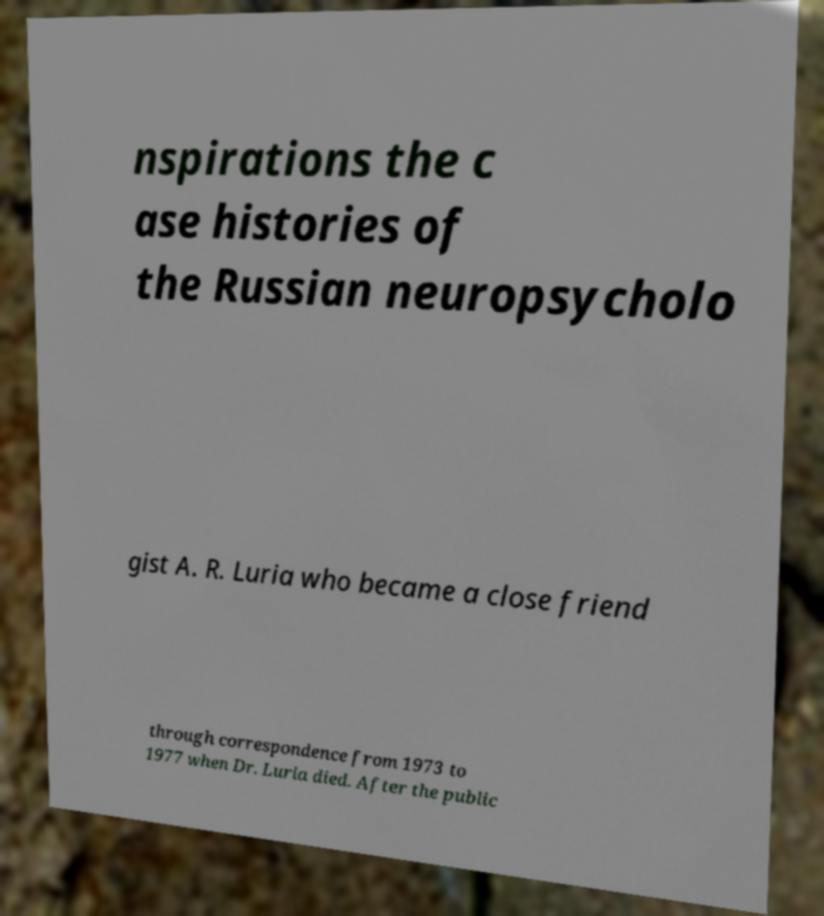For documentation purposes, I need the text within this image transcribed. Could you provide that? nspirations the c ase histories of the Russian neuropsycholo gist A. R. Luria who became a close friend through correspondence from 1973 to 1977 when Dr. Luria died. After the public 